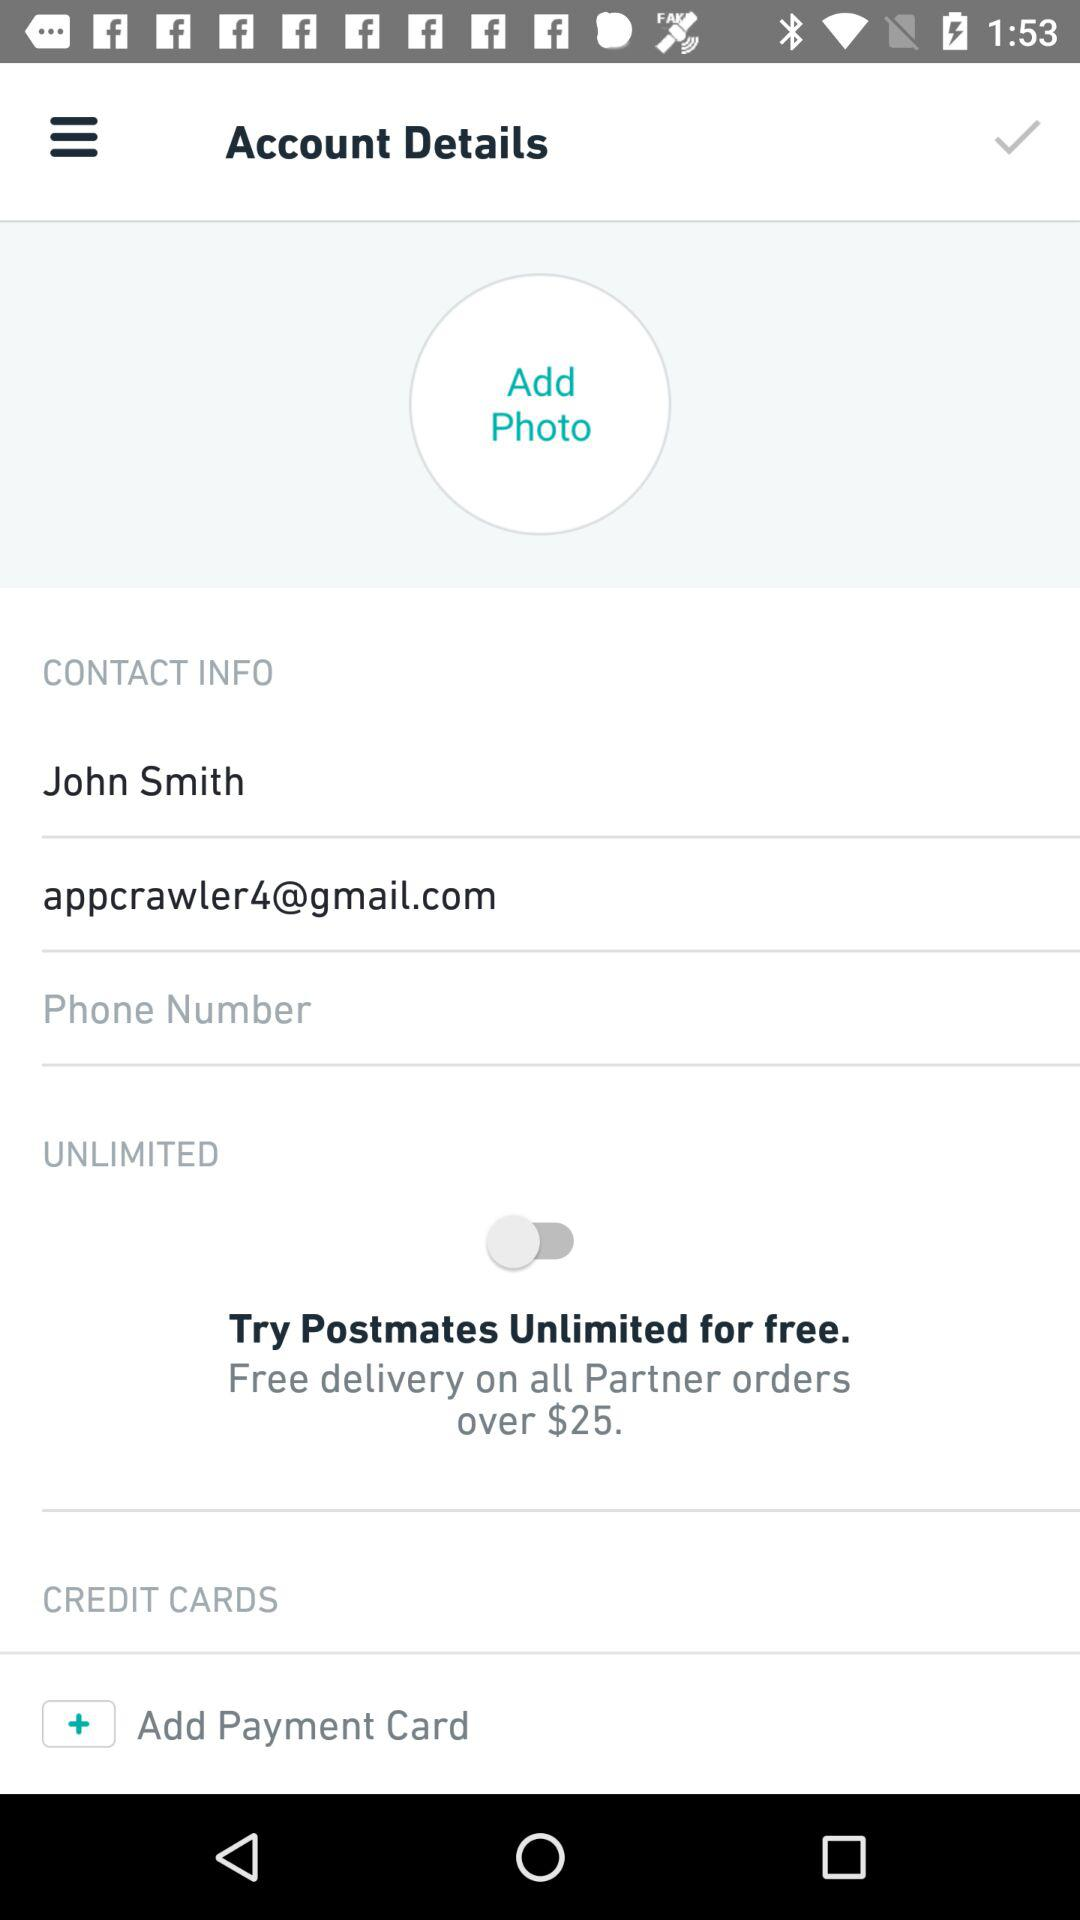What is John Smith's phone number?
When the provided information is insufficient, respond with <no answer>. <no answer> 